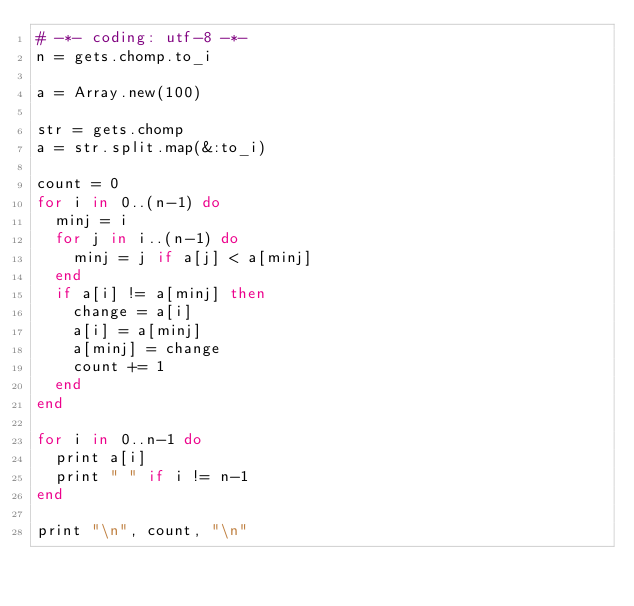<code> <loc_0><loc_0><loc_500><loc_500><_Ruby_># -*- coding: utf-8 -*-
n = gets.chomp.to_i

a = Array.new(100)

str = gets.chomp
a = str.split.map(&:to_i)

count = 0
for i in 0..(n-1) do
  minj = i
  for j in i..(n-1) do
    minj = j if a[j] < a[minj]
  end
  if a[i] != a[minj] then
    change = a[i]
    a[i] = a[minj]
    a[minj] = change
    count += 1
  end
end

for i in 0..n-1 do
  print a[i]
  print " " if i != n-1
end

print "\n", count, "\n"</code> 